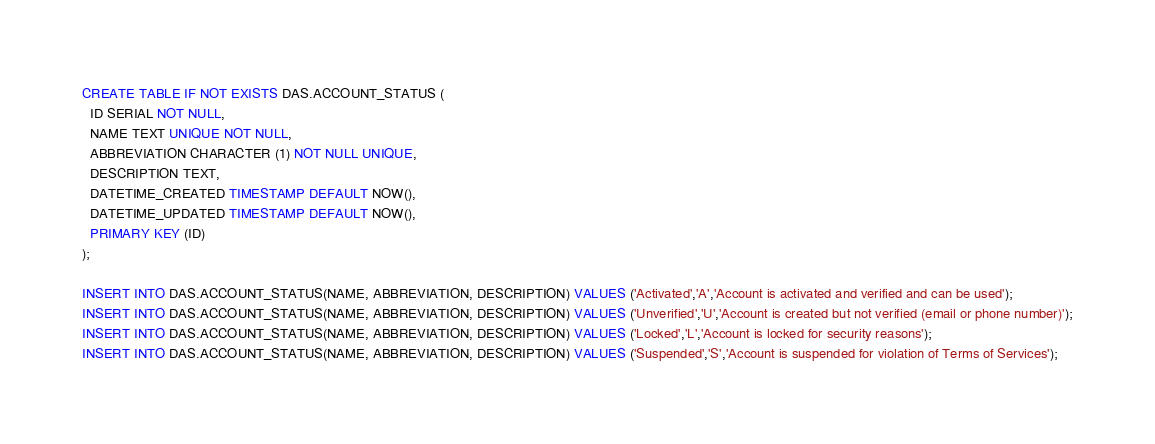Convert code to text. <code><loc_0><loc_0><loc_500><loc_500><_SQL_>CREATE TABLE IF NOT EXISTS DAS.ACCOUNT_STATUS (
  ID SERIAL NOT NULL,
  NAME TEXT UNIQUE NOT NULL,
  ABBREVIATION CHARACTER (1) NOT NULL UNIQUE,
  DESCRIPTION TEXT,
  DATETIME_CREATED TIMESTAMP DEFAULT NOW(),
  DATETIME_UPDATED TIMESTAMP DEFAULT NOW(),
  PRIMARY KEY (ID)
);

INSERT INTO DAS.ACCOUNT_STATUS(NAME, ABBREVIATION, DESCRIPTION) VALUES ('Activated','A','Account is activated and verified and can be used');
INSERT INTO DAS.ACCOUNT_STATUS(NAME, ABBREVIATION, DESCRIPTION) VALUES ('Unverified','U','Account is created but not verified (email or phone number)');
INSERT INTO DAS.ACCOUNT_STATUS(NAME, ABBREVIATION, DESCRIPTION) VALUES ('Locked','L','Account is locked for security reasons');
INSERT INTO DAS.ACCOUNT_STATUS(NAME, ABBREVIATION, DESCRIPTION) VALUES ('Suspended','S','Account is suspended for violation of Terms of Services');</code> 